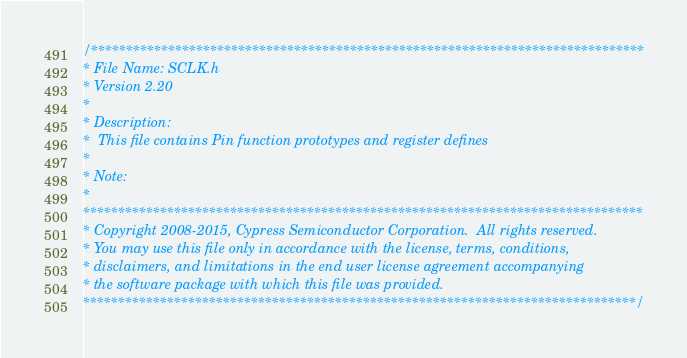Convert code to text. <code><loc_0><loc_0><loc_500><loc_500><_C_>/*******************************************************************************
* File Name: SCLK.h  
* Version 2.20
*
* Description:
*  This file contains Pin function prototypes and register defines
*
* Note:
*
********************************************************************************
* Copyright 2008-2015, Cypress Semiconductor Corporation.  All rights reserved.
* You may use this file only in accordance with the license, terms, conditions, 
* disclaimers, and limitations in the end user license agreement accompanying 
* the software package with which this file was provided.
*******************************************************************************/
</code> 